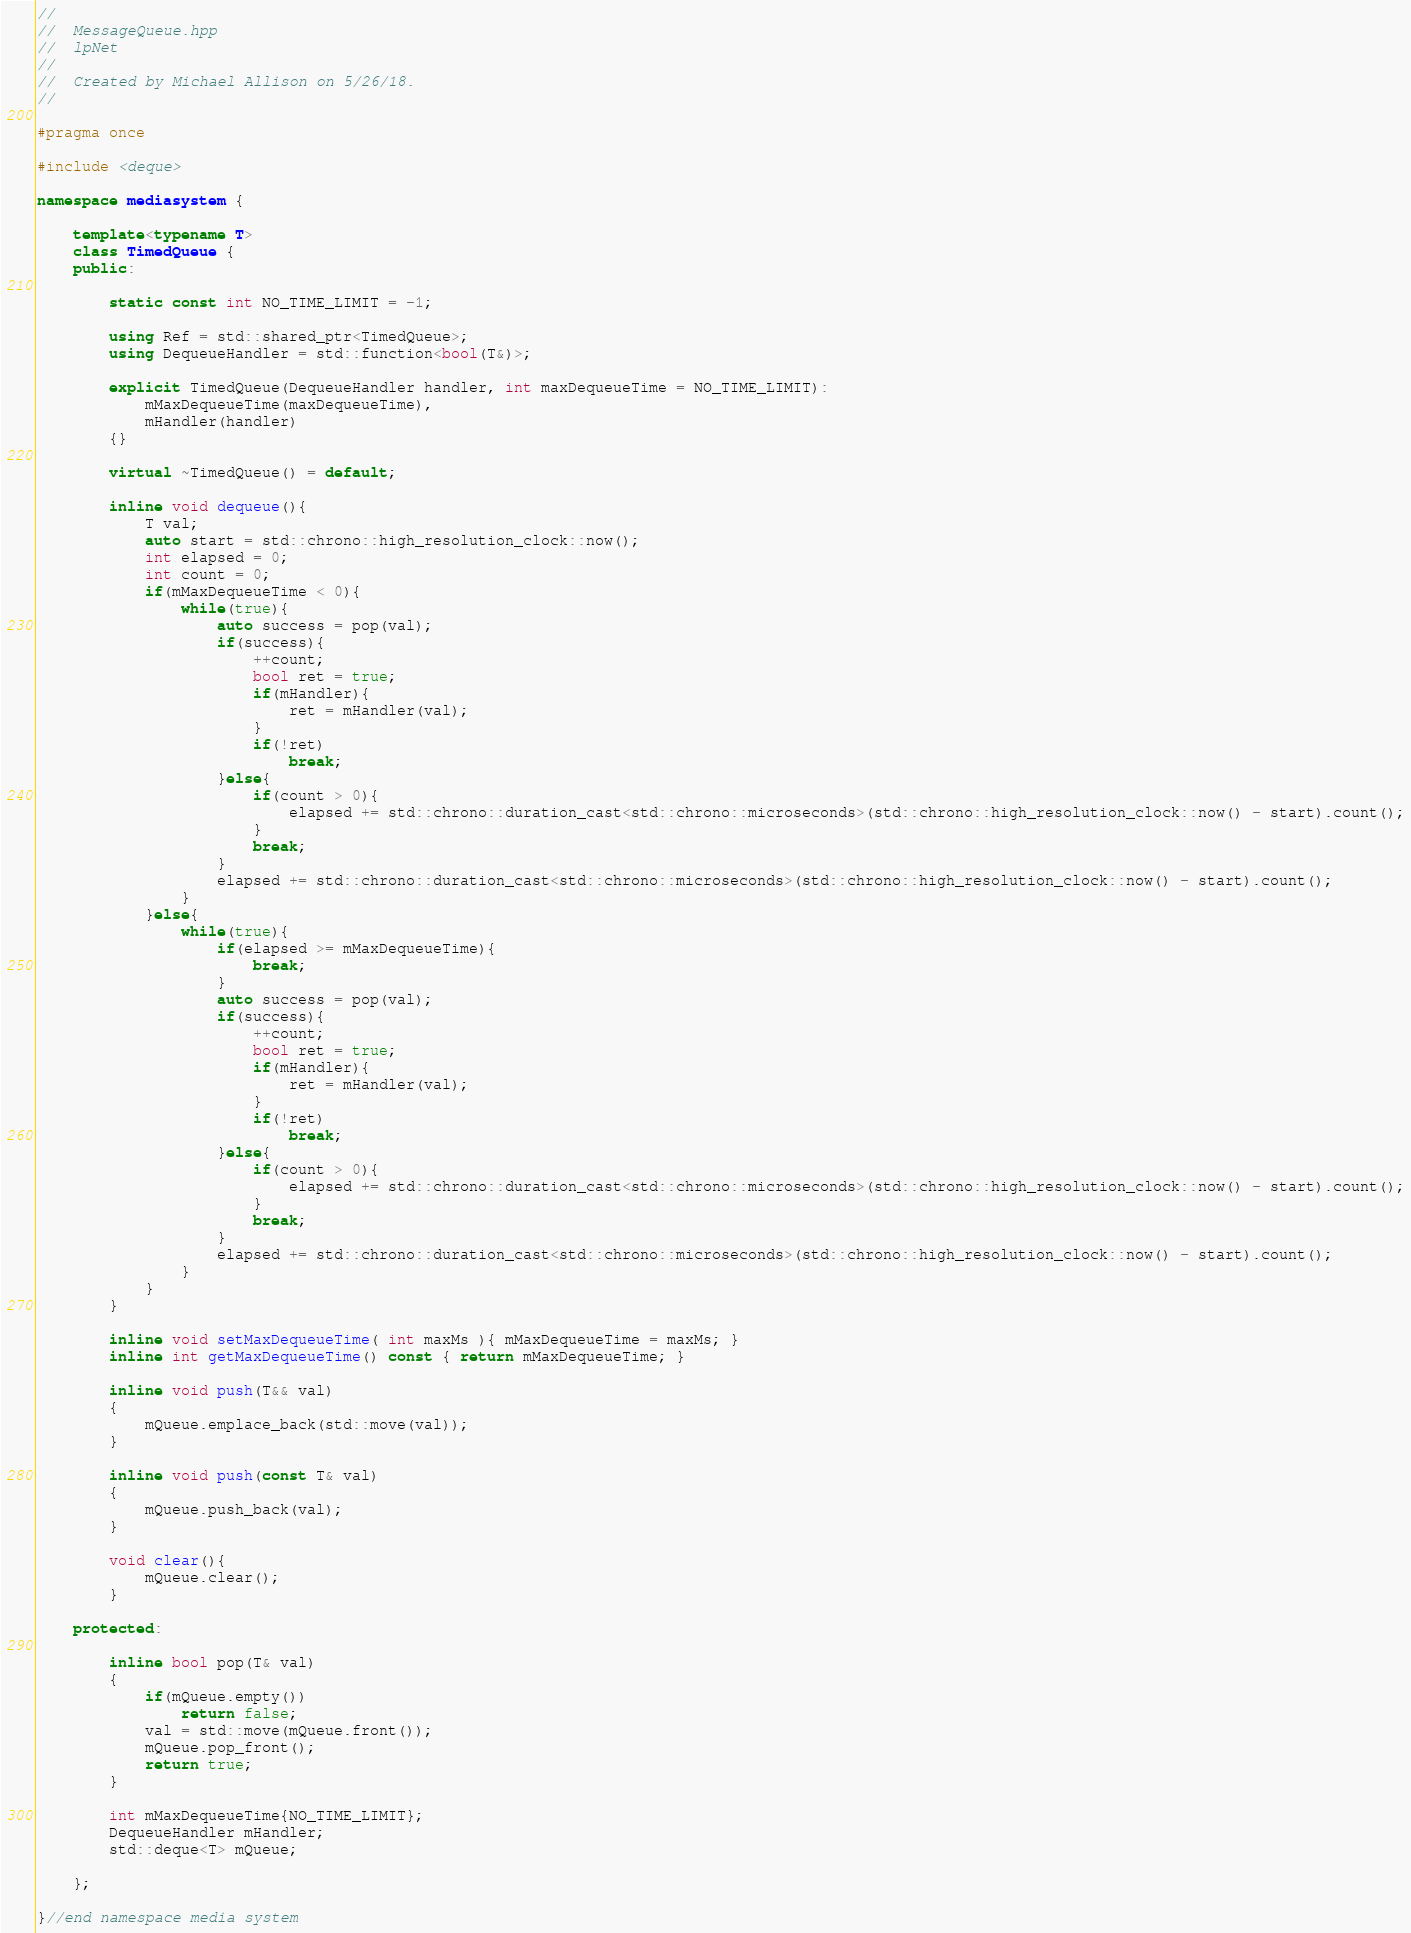Convert code to text. <code><loc_0><loc_0><loc_500><loc_500><_C++_>//
//  MessageQueue.hpp
//  lpNet
//
//  Created by Michael Allison on 5/26/18.
//

#pragma once

#include <deque>

namespace mediasystem {

    template<typename T>
    class TimedQueue {
    public:
        
        static const int NO_TIME_LIMIT = -1;

        using Ref = std::shared_ptr<TimedQueue>;
        using DequeueHandler = std::function<bool(T&)>;
        
        explicit TimedQueue(DequeueHandler handler, int maxDequeueTime = NO_TIME_LIMIT):
            mMaxDequeueTime(maxDequeueTime),
            mHandler(handler)
        {}
        
        virtual ~TimedQueue() = default;
        
        inline void dequeue(){
            T val;
            auto start = std::chrono::high_resolution_clock::now();
            int elapsed = 0;
            int count = 0;
            if(mMaxDequeueTime < 0){
                while(true){
                    auto success = pop(val);
                    if(success){
                        ++count;
                        bool ret = true;
                        if(mHandler){
                            ret = mHandler(val);
                        }
                        if(!ret)
                            break;
                    }else{
                        if(count > 0){
                            elapsed += std::chrono::duration_cast<std::chrono::microseconds>(std::chrono::high_resolution_clock::now() - start).count();
                        }
                        break;
                    }
                    elapsed += std::chrono::duration_cast<std::chrono::microseconds>(std::chrono::high_resolution_clock::now() - start).count();
                }
            }else{
                while(true){
                    if(elapsed >= mMaxDequeueTime){
                        break;
                    }
                    auto success = pop(val);
                    if(success){
                        ++count;
                        bool ret = true;
                        if(mHandler){
                            ret = mHandler(val);
                        }
                        if(!ret)
                            break;
                    }else{
                        if(count > 0){
                            elapsed += std::chrono::duration_cast<std::chrono::microseconds>(std::chrono::high_resolution_clock::now() - start).count();
                        }
                        break;
                    }
                    elapsed += std::chrono::duration_cast<std::chrono::microseconds>(std::chrono::high_resolution_clock::now() - start).count();
                }
            }
        }
        
        inline void setMaxDequeueTime( int maxMs ){ mMaxDequeueTime = maxMs; }
        inline int getMaxDequeueTime() const { return mMaxDequeueTime; }
        
        inline void push(T&& val)
        {
            mQueue.emplace_back(std::move(val));
        }
        
        inline void push(const T& val)
        {
            mQueue.push_back(val);
        }
        
        void clear(){
            mQueue.clear();
        }

    protected:
        
        inline bool pop(T& val)
        {
            if(mQueue.empty())
                return false;
            val = std::move(mQueue.front());
            mQueue.pop_front();
            return true;
        }
        
        int mMaxDequeueTime{NO_TIME_LIMIT};
        DequeueHandler mHandler;
        std::deque<T> mQueue;
        
    };

}//end namespace media system
</code> 